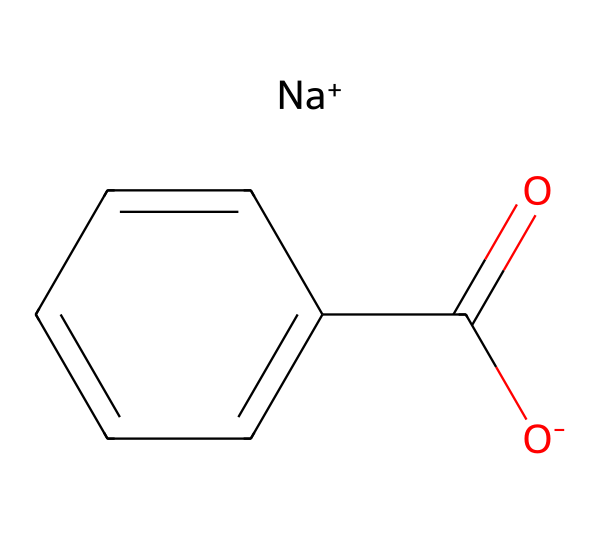What is the parent compound of sodium benzoate? The structure includes a benzene ring with a carboxylate group, indicating that benzoate is derived from benzoic acid.
Answer: benzoic acid How many carbon atoms are present in sodium benzoate? The SMILES representation shows a total of 7 carbon atoms: 6 from the benzene ring and 1 from the carboxylate group.
Answer: 7 What is the charge of the sodium ion in sodium benzoate? The notation [Na+] indicates that the sodium ion has a positive charge.
Answer: positive What type of functional group is present in sodium benzoate? The chemical structure shows a carboxylate group (C(=O)O-), which is characteristic of carboxylic acids.
Answer: carboxylate Is sodium benzoate soluble in water? Sodium benzoate, as a salt formed from a weak acid and a strong base, is generally soluble in water.
Answer: soluble How many double bonds are there in the chemical structure of sodium benzoate? In the provided structure, there is one double bond in the carbonyl group of the carboxylate, represented as C(=O).
Answer: 1 